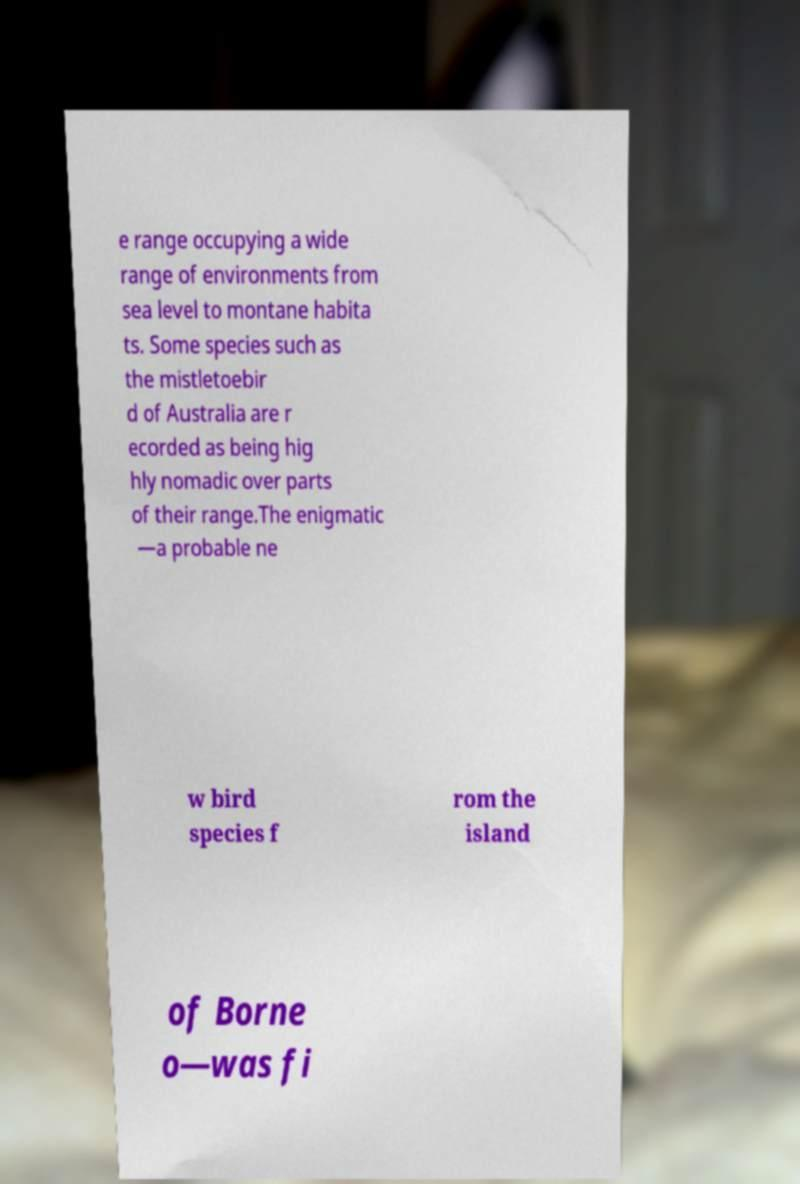Can you read and provide the text displayed in the image?This photo seems to have some interesting text. Can you extract and type it out for me? e range occupying a wide range of environments from sea level to montane habita ts. Some species such as the mistletoebir d of Australia are r ecorded as being hig hly nomadic over parts of their range.The enigmatic —a probable ne w bird species f rom the island of Borne o—was fi 